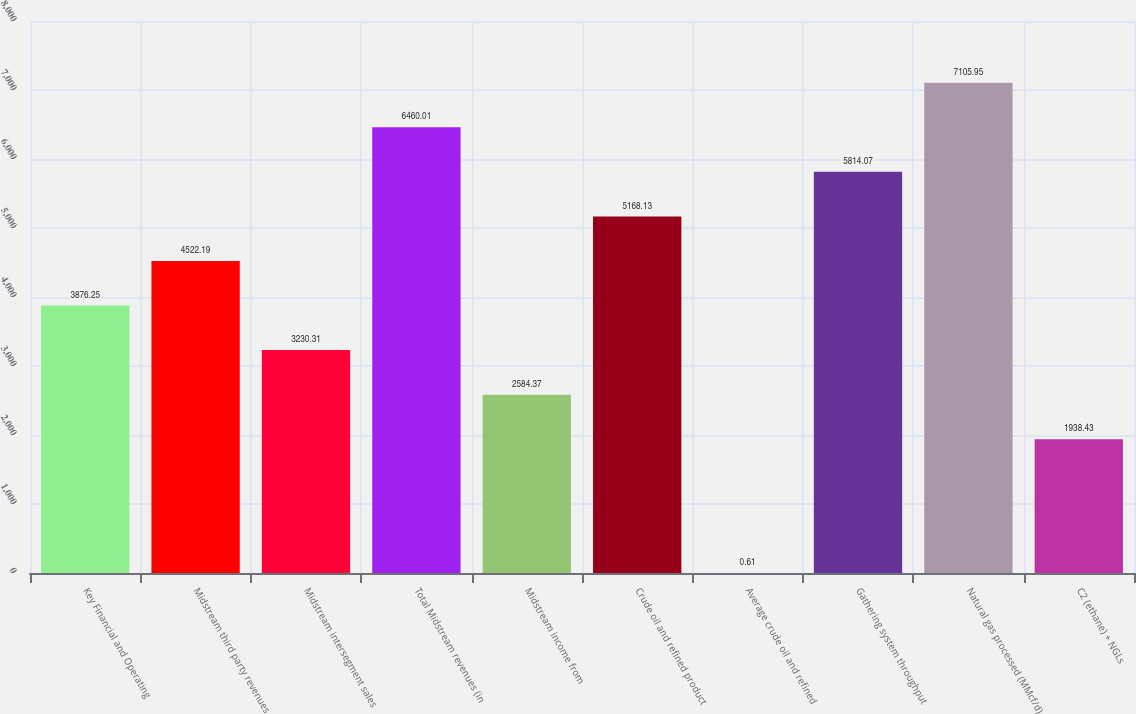Convert chart. <chart><loc_0><loc_0><loc_500><loc_500><bar_chart><fcel>Key Financial and Operating<fcel>Midstream third party revenues<fcel>Midstream intersegment sales<fcel>Total Midstream revenues (in<fcel>Midstream income from<fcel>Crude oil and refined product<fcel>Average crude oil and refined<fcel>Gathering system throughput<fcel>Natural gas processed (MMcf/d)<fcel>C2 (ethane) + NGLs<nl><fcel>3876.25<fcel>4522.19<fcel>3230.31<fcel>6460.01<fcel>2584.37<fcel>5168.13<fcel>0.61<fcel>5814.07<fcel>7105.95<fcel>1938.43<nl></chart> 